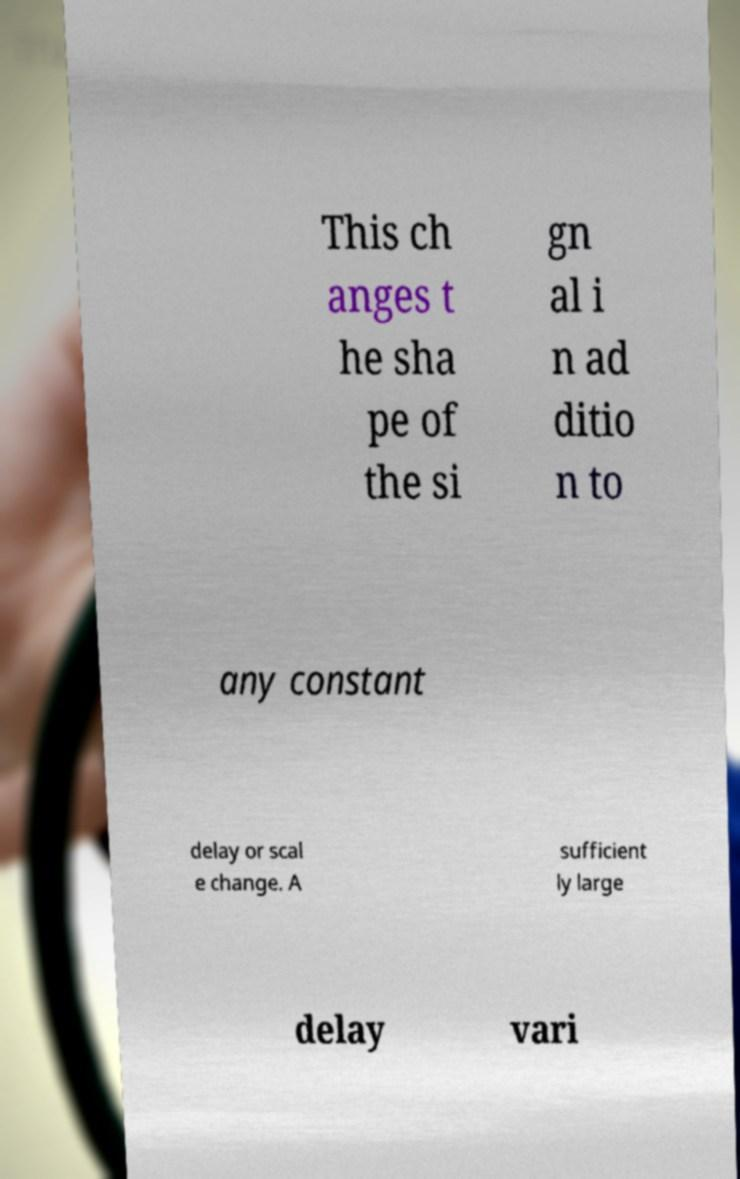Can you accurately transcribe the text from the provided image for me? This ch anges t he sha pe of the si gn al i n ad ditio n to any constant delay or scal e change. A sufficient ly large delay vari 